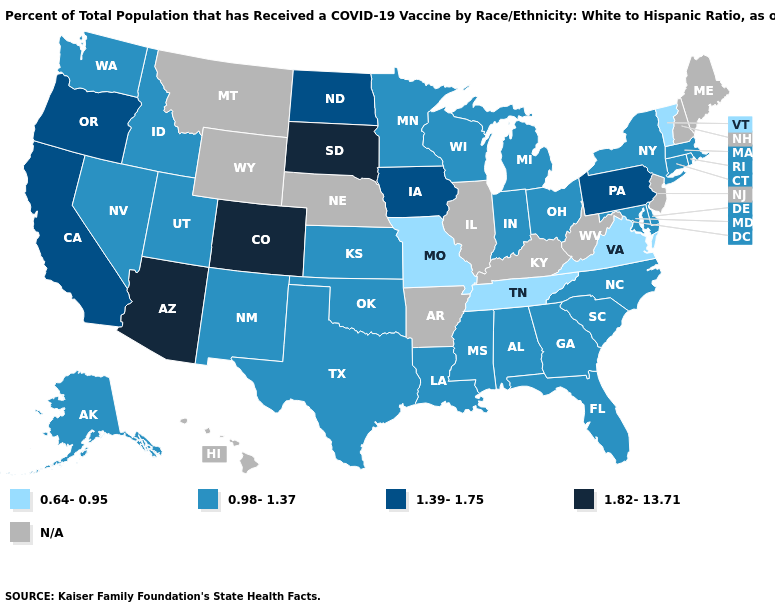Among the states that border Mississippi , which have the lowest value?
Be succinct. Tennessee. What is the value of New Hampshire?
Keep it brief. N/A. Does Virginia have the lowest value in the USA?
Write a very short answer. Yes. What is the value of Utah?
Give a very brief answer. 0.98-1.37. What is the value of North Carolina?
Short answer required. 0.98-1.37. Is the legend a continuous bar?
Give a very brief answer. No. Which states have the highest value in the USA?
Keep it brief. Arizona, Colorado, South Dakota. What is the highest value in the USA?
Quick response, please. 1.82-13.71. Which states have the lowest value in the USA?
Be succinct. Missouri, Tennessee, Vermont, Virginia. Which states have the lowest value in the USA?
Concise answer only. Missouri, Tennessee, Vermont, Virginia. Which states hav the highest value in the Northeast?
Answer briefly. Pennsylvania. Name the states that have a value in the range 1.39-1.75?
Be succinct. California, Iowa, North Dakota, Oregon, Pennsylvania. 